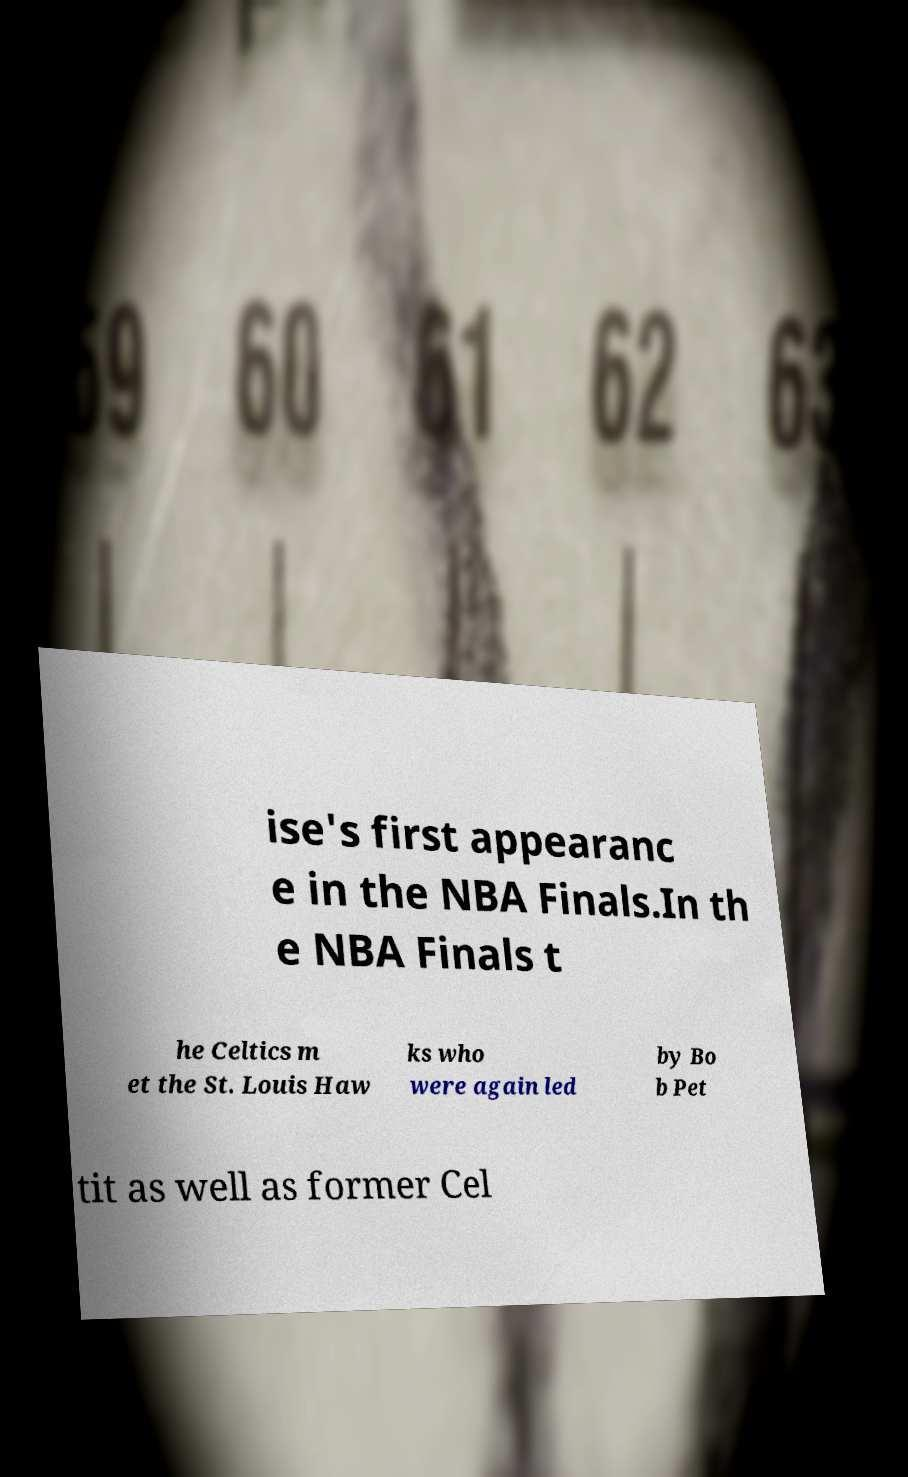Can you accurately transcribe the text from the provided image for me? ise's first appearanc e in the NBA Finals.In th e NBA Finals t he Celtics m et the St. Louis Haw ks who were again led by Bo b Pet tit as well as former Cel 